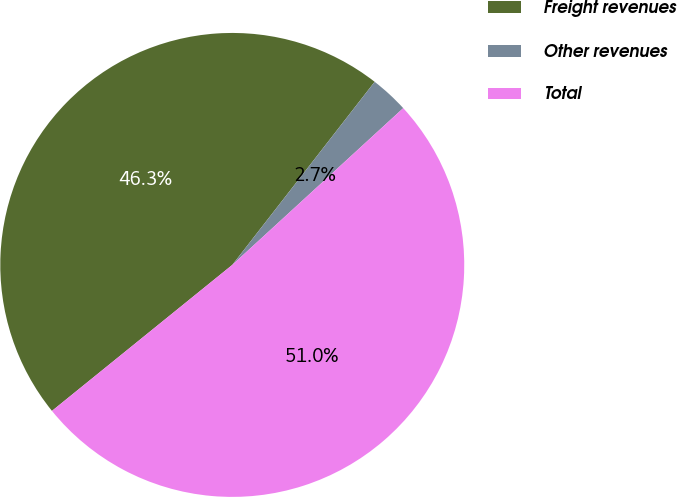Convert chart. <chart><loc_0><loc_0><loc_500><loc_500><pie_chart><fcel>Freight revenues<fcel>Other revenues<fcel>Total<nl><fcel>46.35%<fcel>2.67%<fcel>50.98%<nl></chart> 